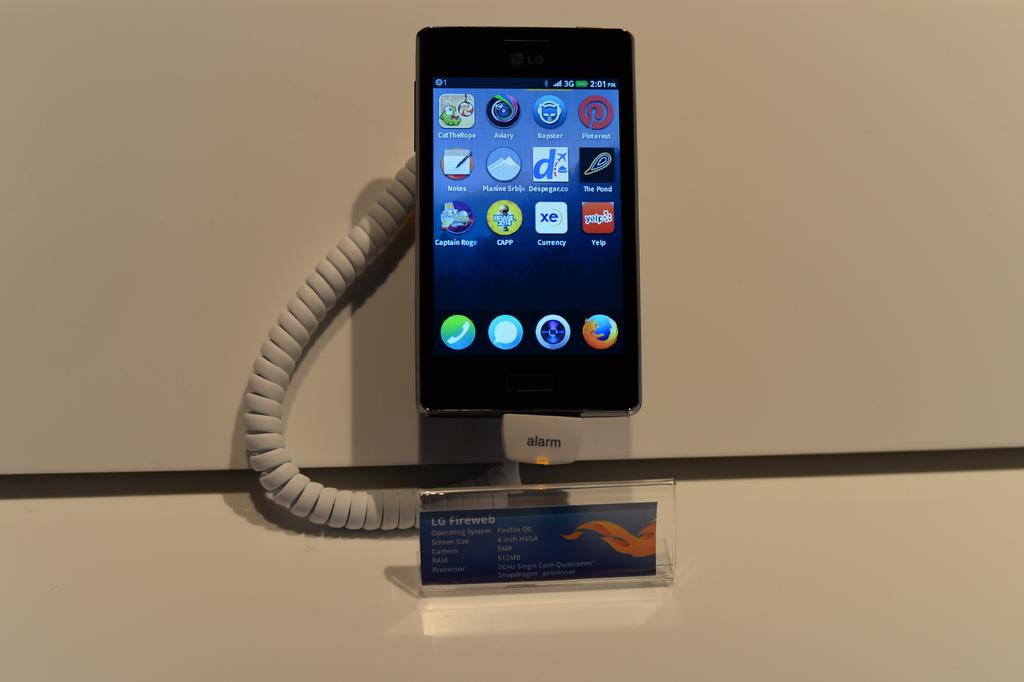Provide a one-sentence caption for the provided image. An LG Fireweb smartphone with Firefox OS operating system. 